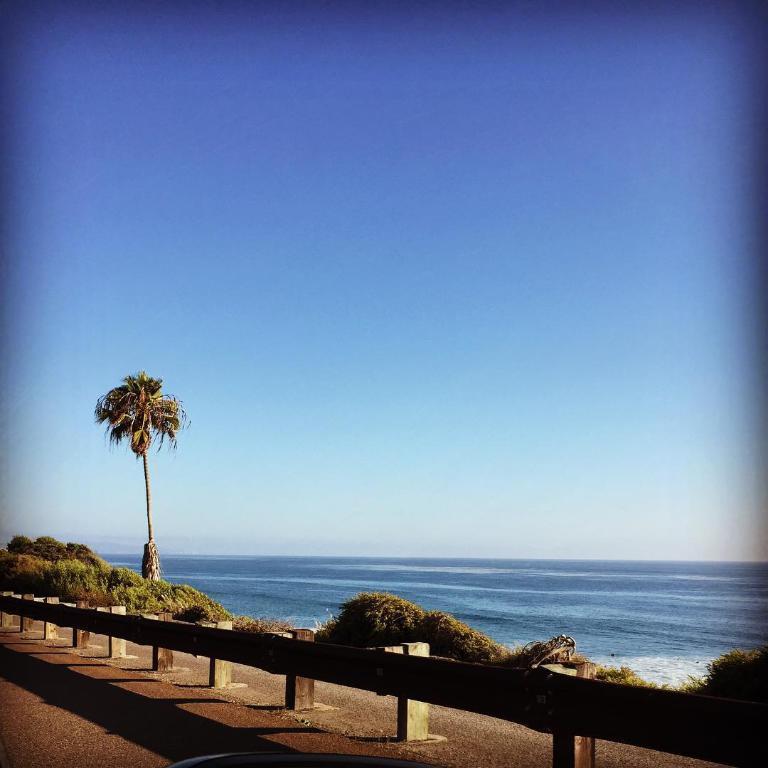In one or two sentences, can you explain what this image depicts? In this picture there is a boundary at the bottom side of the image and there is a tree on the left side of the image, there are plants at the bottom side of the image and there is water in the background area of the image. 